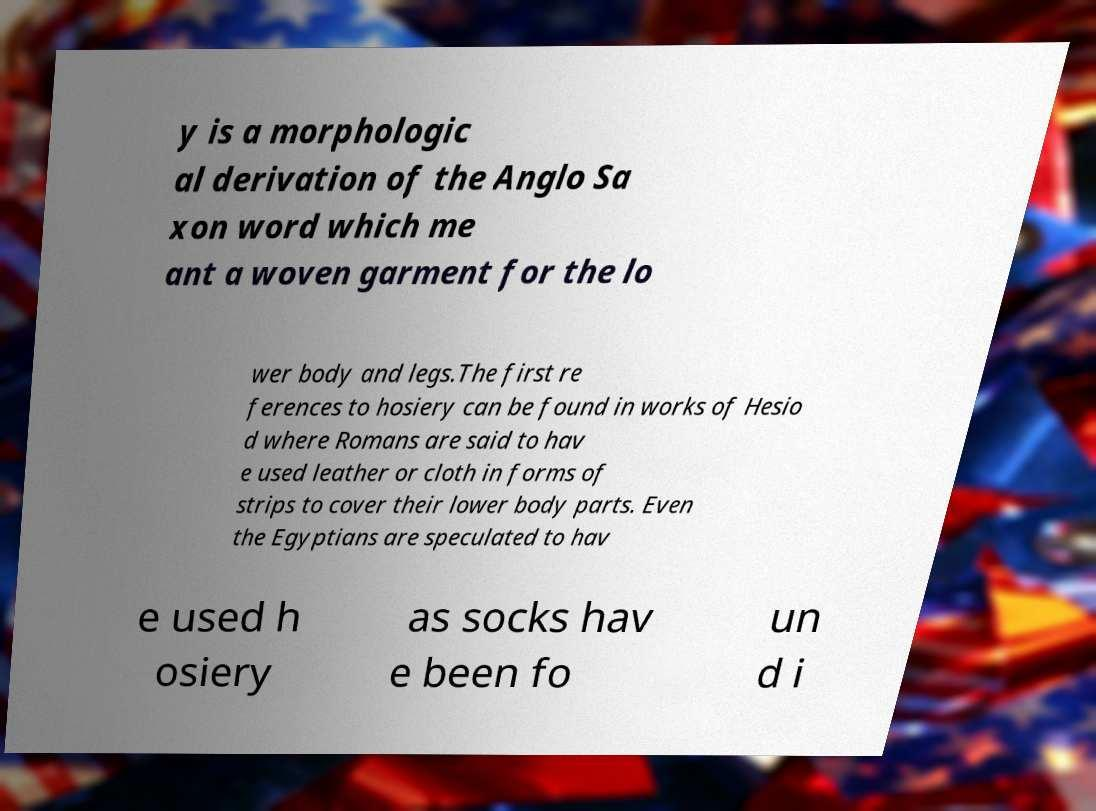Can you read and provide the text displayed in the image?This photo seems to have some interesting text. Can you extract and type it out for me? y is a morphologic al derivation of the Anglo Sa xon word which me ant a woven garment for the lo wer body and legs.The first re ferences to hosiery can be found in works of Hesio d where Romans are said to hav e used leather or cloth in forms of strips to cover their lower body parts. Even the Egyptians are speculated to hav e used h osiery as socks hav e been fo un d i 